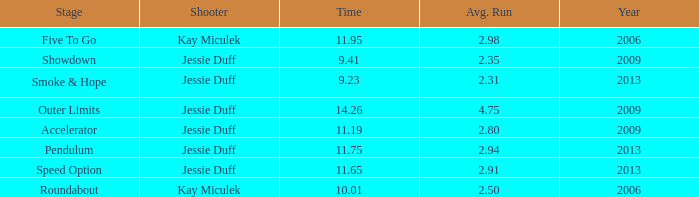What is the total amount of time for years prior to 2013 when speed option is the stage? None. 